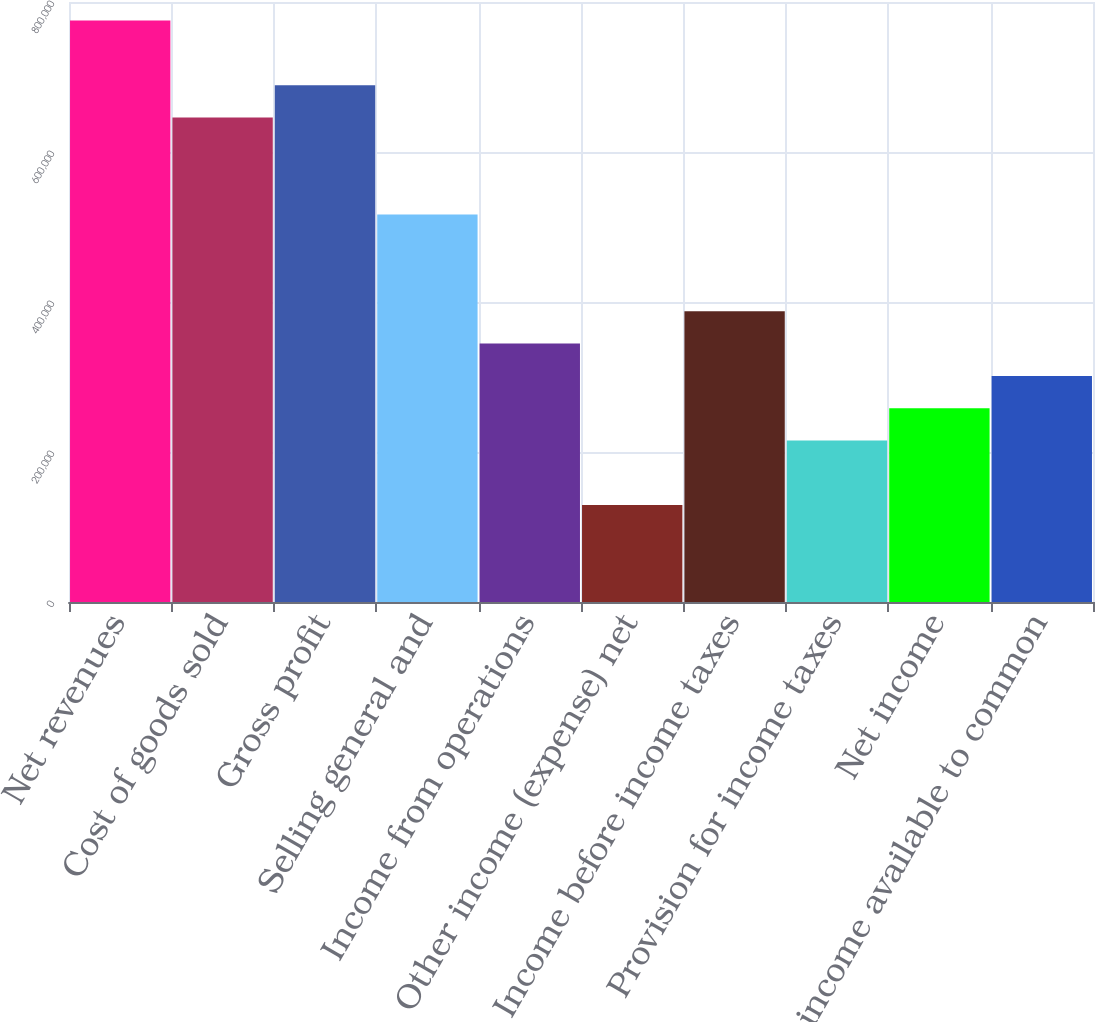<chart> <loc_0><loc_0><loc_500><loc_500><bar_chart><fcel>Net revenues<fcel>Cost of goods sold<fcel>Gross profit<fcel>Selling general and<fcel>Income from operations<fcel>Other income (expense) net<fcel>Income before income taxes<fcel>Provision for income taxes<fcel>Net income<fcel>Net income available to common<nl><fcel>775240<fcel>646033<fcel>689102<fcel>516827<fcel>344551<fcel>129207<fcel>387620<fcel>215345<fcel>258414<fcel>301483<nl></chart> 